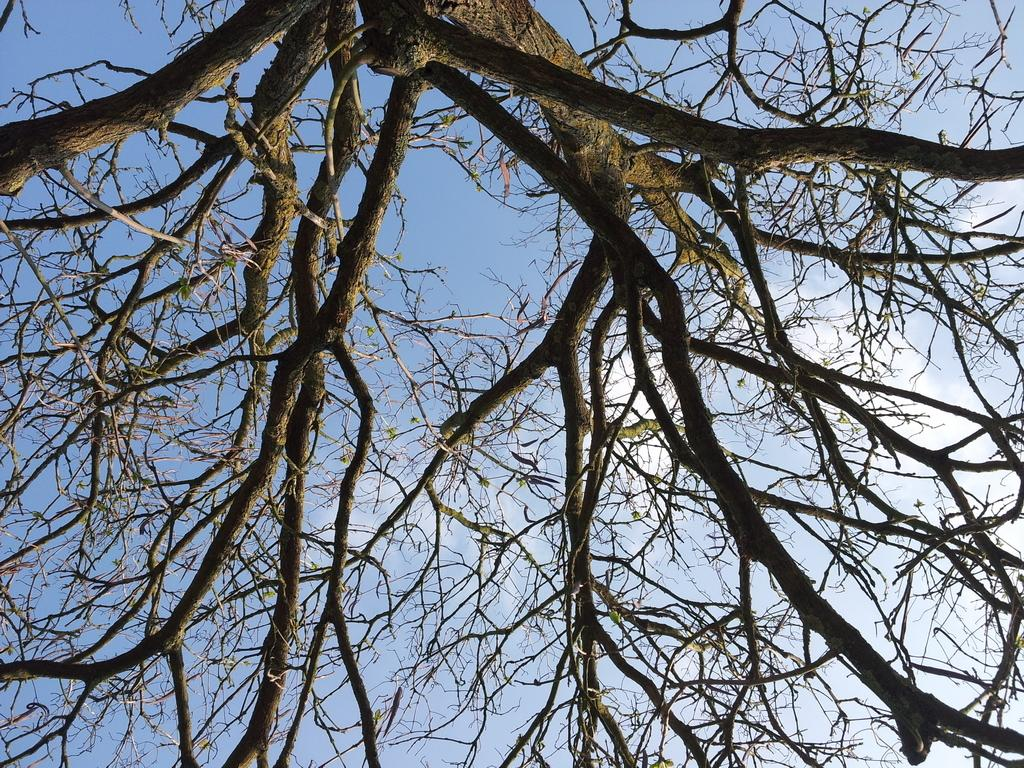What type of plant is in the image? There is a tree in the image. What are the tree's main features? The tree has branches and stems. What is visible in the background of the image? The sky is visible in the background of the image. Can you tell me how many ships are visible in the image? There are no ships present in the image. What type of roll can be seen being performed by the tree in the image? There is no roll being performed by the tree in the image, as trees do not have the ability to perform rolls. 